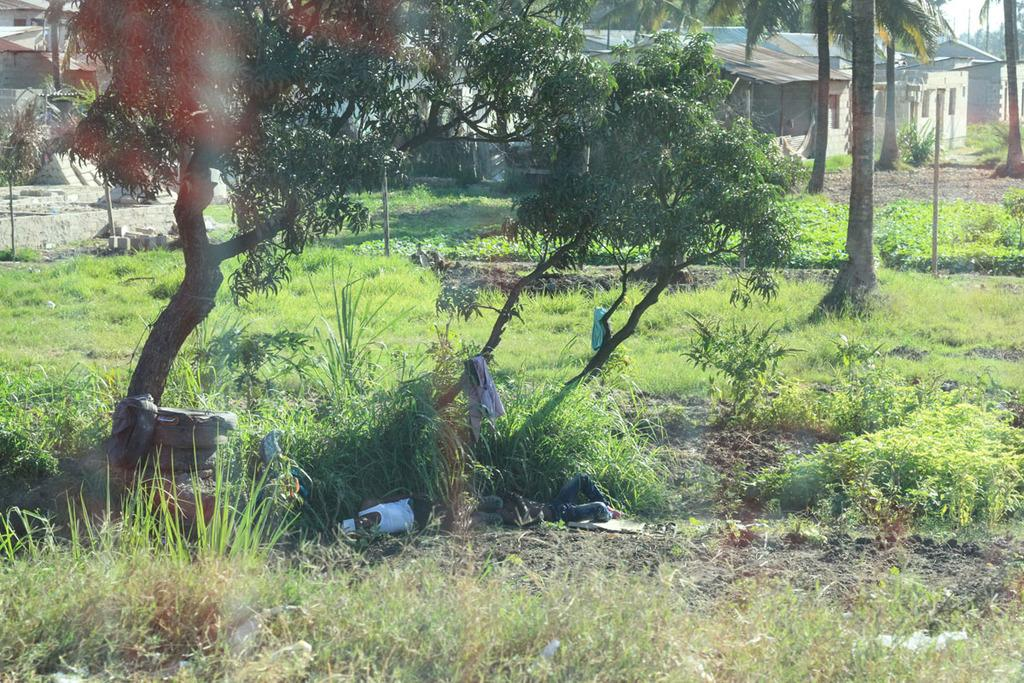What type of vegetation is present in the image? There is grass, plants, and trees in the image. Can you describe the natural elements in the image? The natural elements include grass, plants, and trees. What can be seen in the background of the image? There are houses in the background of the image. Is there a lake visible in the image? No, there is no lake present in the image. What type of expansion is occurring in the front of the image? There is no expansion mentioned or visible in the image. 